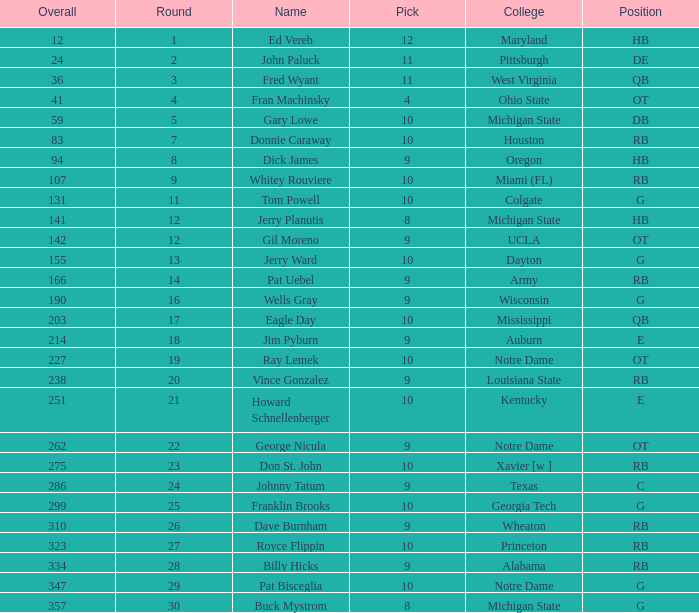What is the sum of rounds that has a pick of 9 and is named jim pyburn? 18.0. 